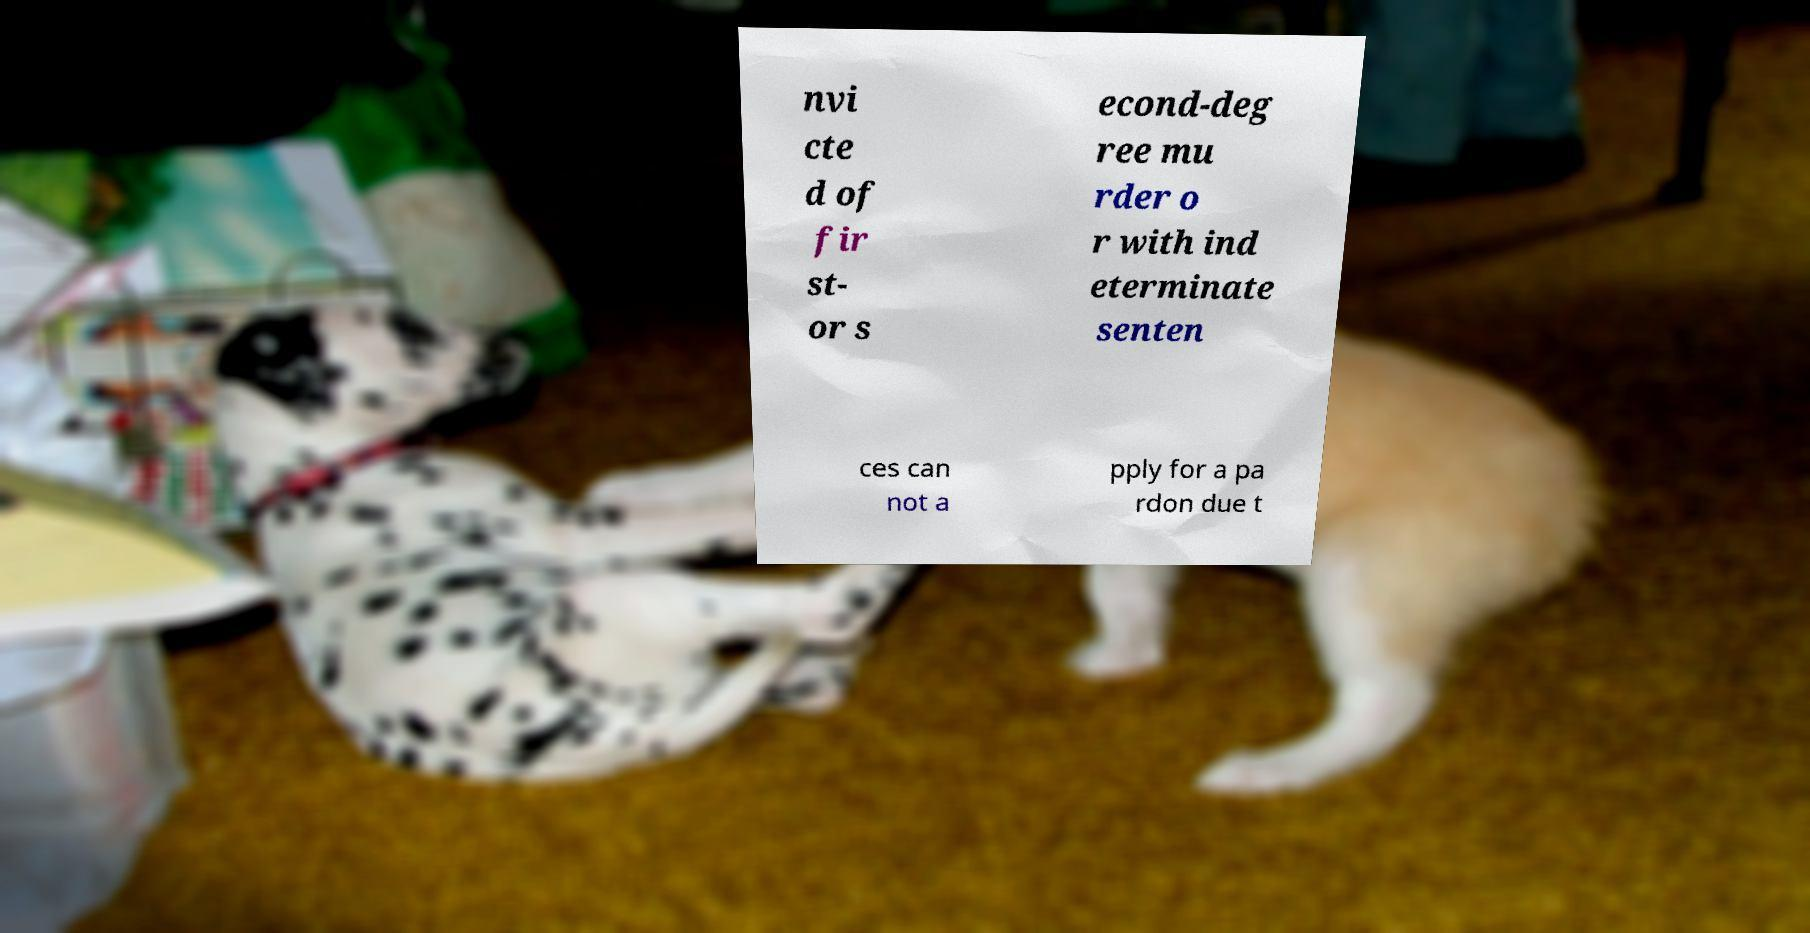Could you extract and type out the text from this image? nvi cte d of fir st- or s econd-deg ree mu rder o r with ind eterminate senten ces can not a pply for a pa rdon due t 